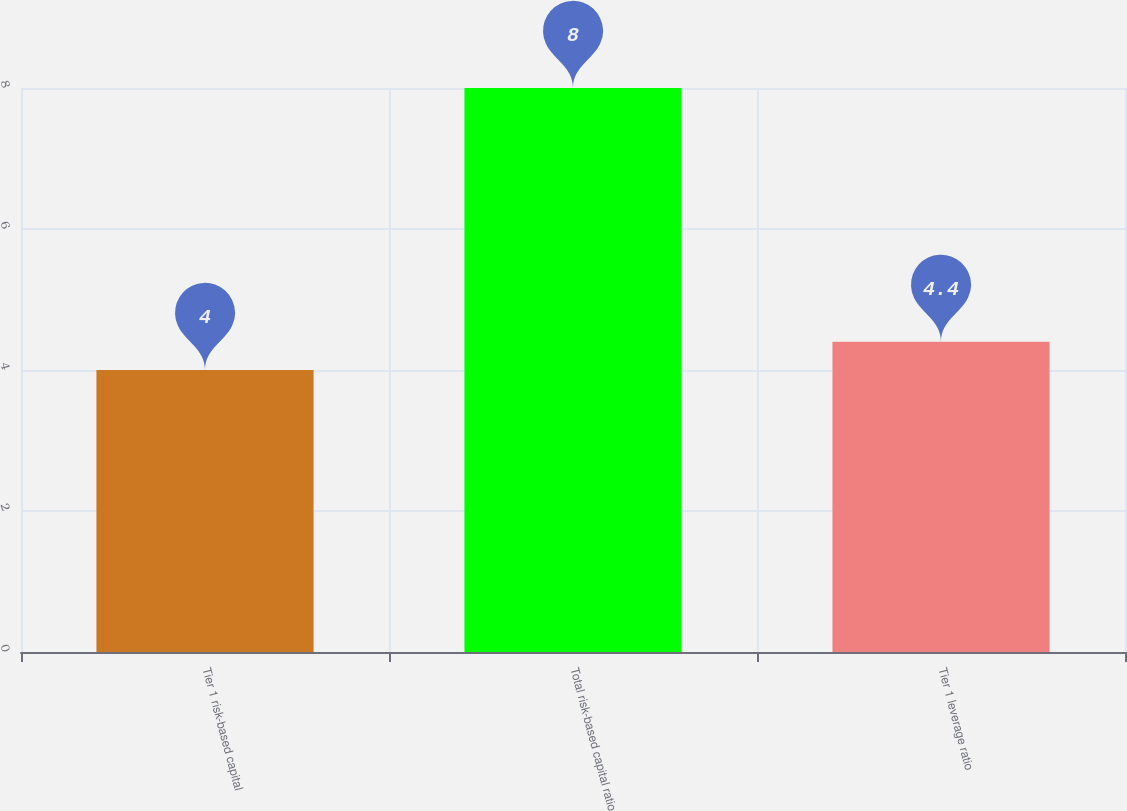Convert chart. <chart><loc_0><loc_0><loc_500><loc_500><bar_chart><fcel>Tier 1 risk-based capital<fcel>Total risk-based capital ratio<fcel>Tier 1 leverage ratio<nl><fcel>4<fcel>8<fcel>4.4<nl></chart> 